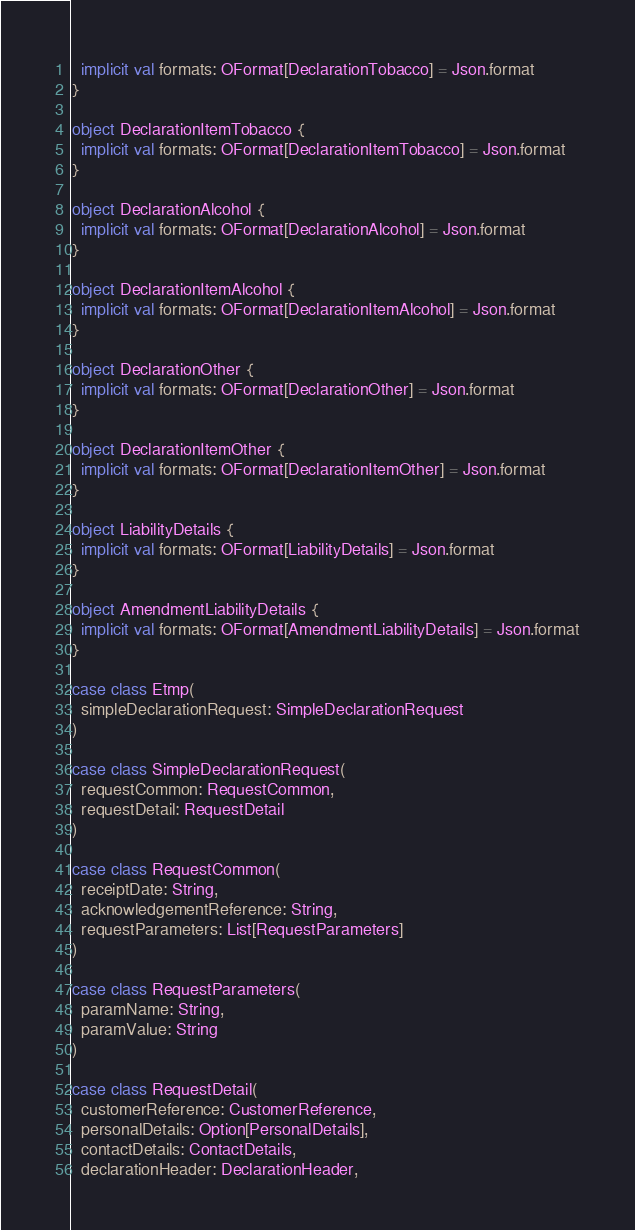<code> <loc_0><loc_0><loc_500><loc_500><_Scala_>  implicit val formats: OFormat[DeclarationTobacco] = Json.format
}

object DeclarationItemTobacco {
  implicit val formats: OFormat[DeclarationItemTobacco] = Json.format
}

object DeclarationAlcohol {
  implicit val formats: OFormat[DeclarationAlcohol] = Json.format
}

object DeclarationItemAlcohol {
  implicit val formats: OFormat[DeclarationItemAlcohol] = Json.format
}

object DeclarationOther {
  implicit val formats: OFormat[DeclarationOther] = Json.format
}

object DeclarationItemOther {
  implicit val formats: OFormat[DeclarationItemOther] = Json.format
}

object LiabilityDetails {
  implicit val formats: OFormat[LiabilityDetails] = Json.format
}

object AmendmentLiabilityDetails {
  implicit val formats: OFormat[AmendmentLiabilityDetails] = Json.format
}

case class Etmp(
  simpleDeclarationRequest: SimpleDeclarationRequest
)

case class SimpleDeclarationRequest(
  requestCommon: RequestCommon,
  requestDetail: RequestDetail
)

case class RequestCommon(
  receiptDate: String,
  acknowledgementReference: String,
  requestParameters: List[RequestParameters]
)

case class RequestParameters(
  paramName: String,
  paramValue: String
)

case class RequestDetail(
  customerReference: CustomerReference,
  personalDetails: Option[PersonalDetails],
  contactDetails: ContactDetails,
  declarationHeader: DeclarationHeader,</code> 